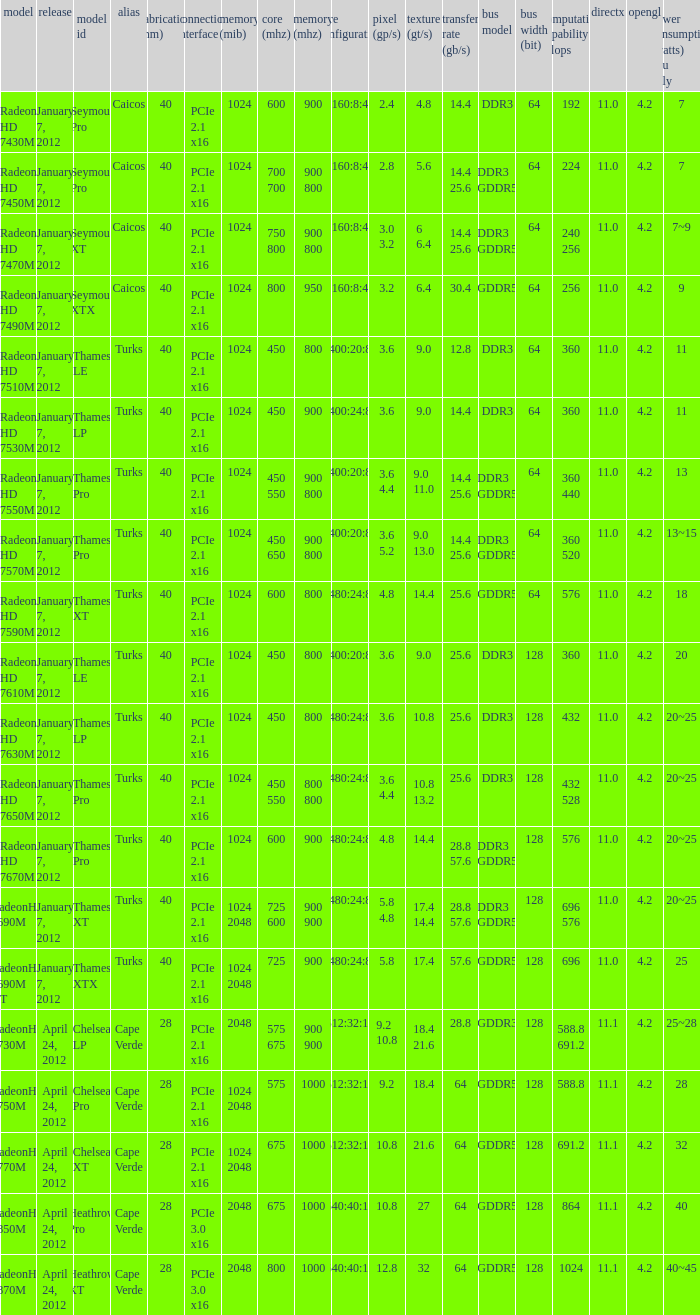How many texture (gt/s) the card has if the tdp (watts) GPU only is 18? 1.0. 